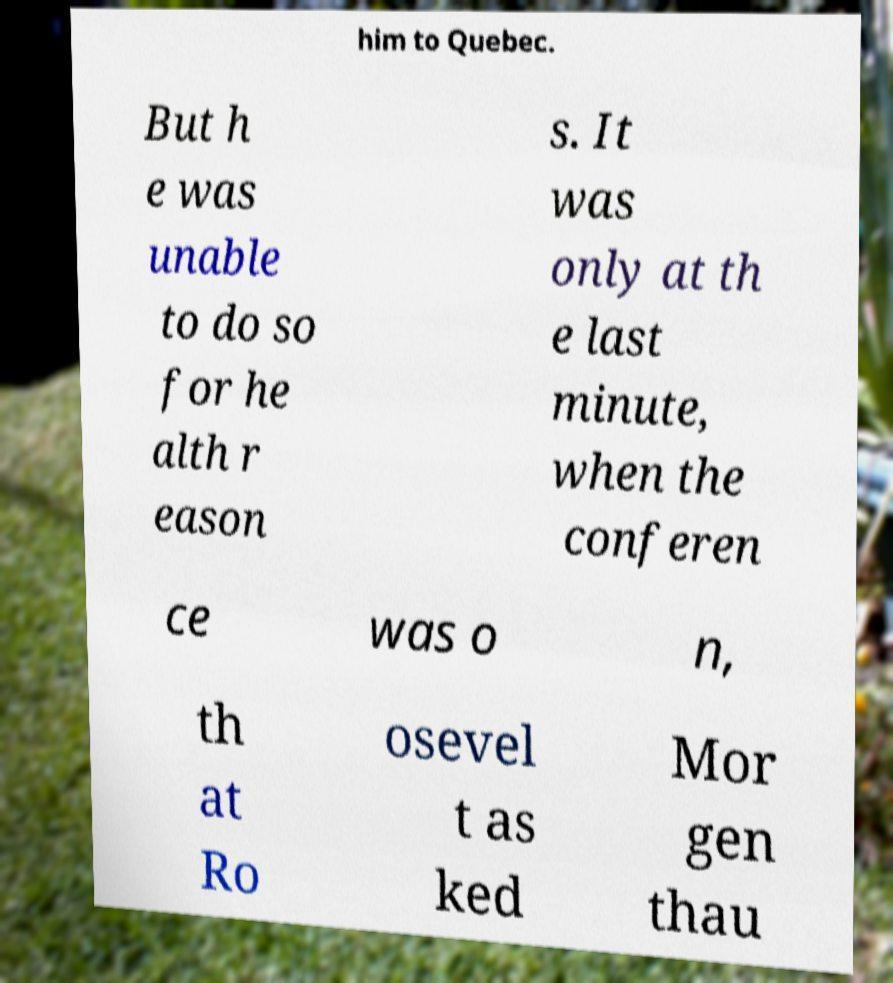Please identify and transcribe the text found in this image. him to Quebec. But h e was unable to do so for he alth r eason s. It was only at th e last minute, when the conferen ce was o n, th at Ro osevel t as ked Mor gen thau 